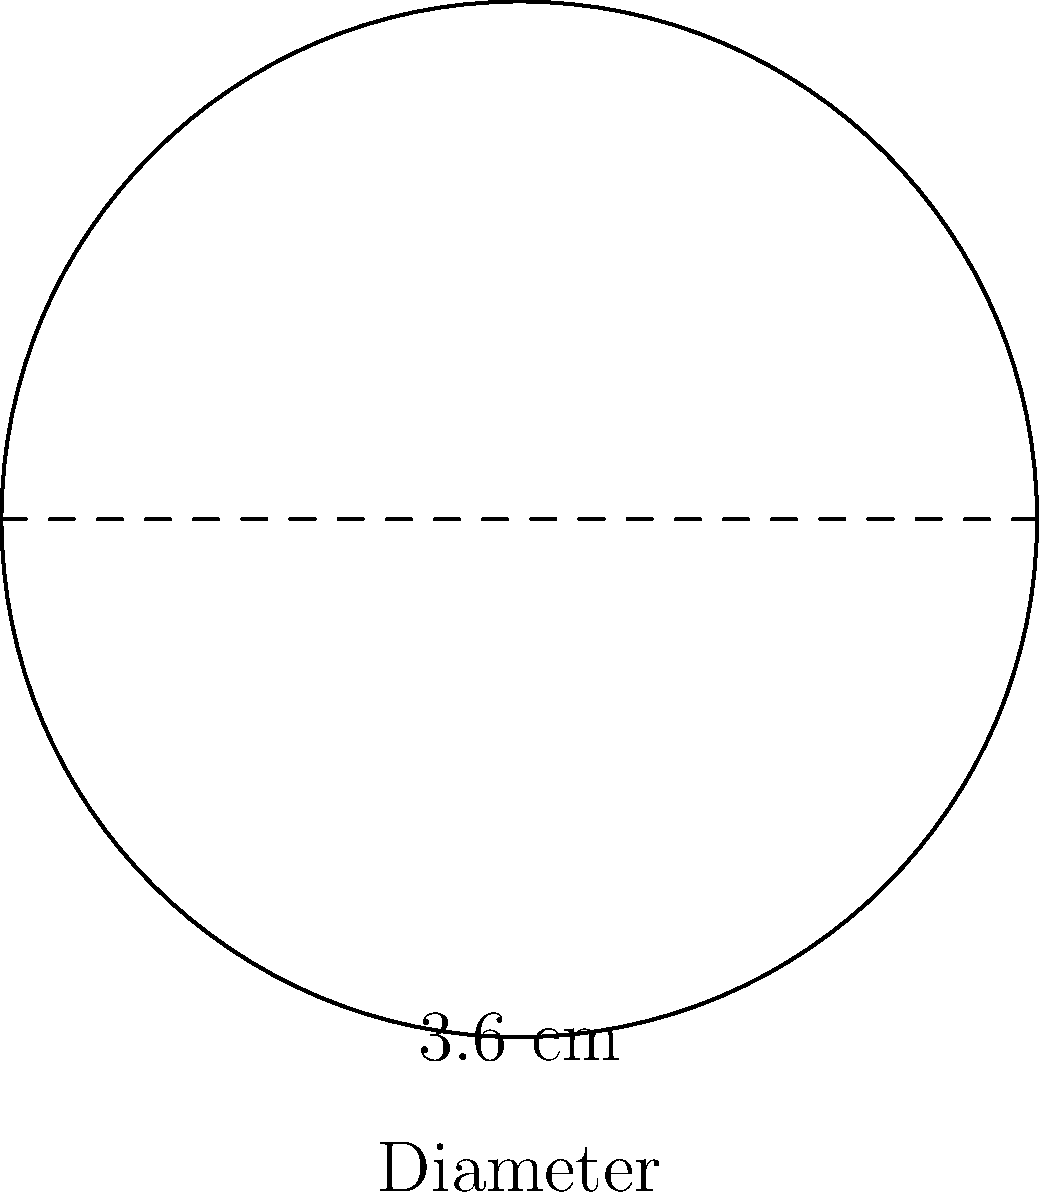Imagine you're holding a sliotar before a big match in Semple Stadium. If the diameter of the sliotar is 3.6 cm, what's the circumference of the ball? (Use $\pi = 3.14$ for your calculations and round your answer to the nearest millimeter) Let's approach this step-by-step:

1) We know that the diameter of the sliotar is 3.6 cm.

2) The formula for the circumference of a circle is:
   $$C = \pi d$$
   where $C$ is the circumference, $\pi$ is pi, and $d$ is the diameter.

3) We're given that $\pi = 3.14$ and $d = 3.6$ cm.

4) Let's substitute these values into our formula:
   $$C = 3.14 \times 3.6$$

5) Now let's calculate:
   $$C = 11.304 \text{ cm}$$

6) Rounding to the nearest millimeter (0.1 cm):
   $$C \approx 11.3 \text{ cm}$$

So, the circumference of the sliotar is approximately 11.3 cm.
Answer: 11.3 cm 